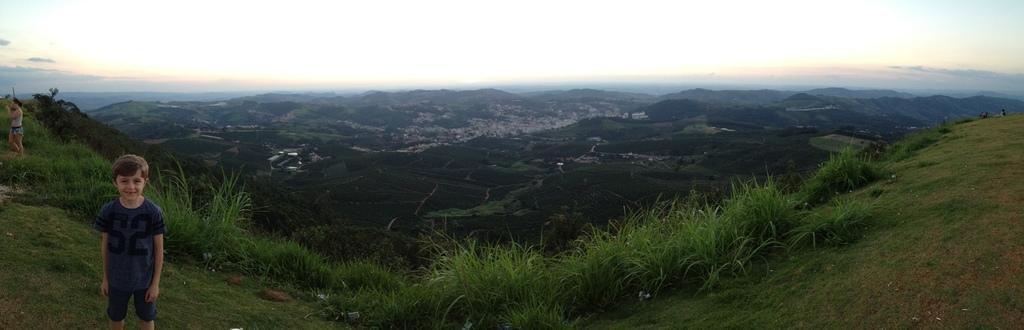How would you summarize this image in a sentence or two? In this picture I can see a woman and a boy standing. I can see buildings, trees, hills and a blue cloudy sky. I can see grass on the ground. 